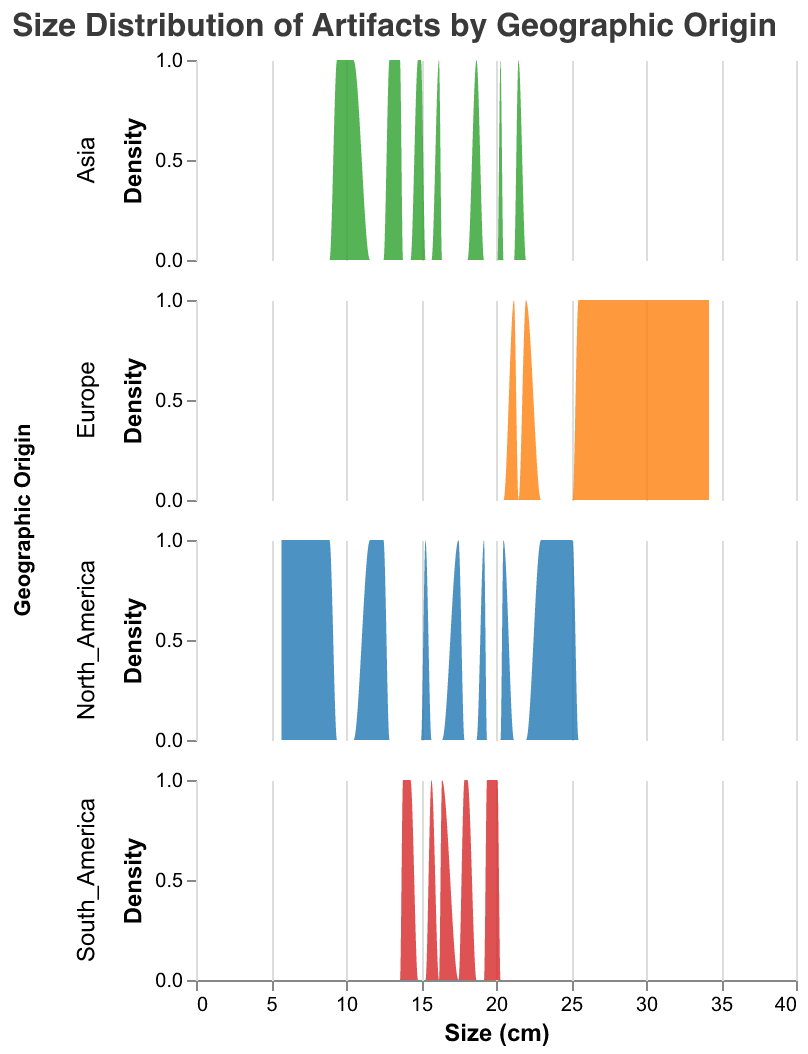What is the title of the figure? The title is given at the top of the figure, which is usually in a larger font size and often in a different color to stand out.
Answer: Size Distribution of Artifacts by Geographic Origin What is the x-axis representing in the figure? The x-axis is labeled "Size (cm)" and represents the size of the artifacts in centimeters.
Answer: Size (cm) Which geographic origin has artifacts with the largest maximum size? Look at the artifact sizes for each geographic origin. The largest maximum size can be identified from the highest data point in each subplot, which for Europe is about 34.2 cm.
Answer: Europe How does the size distribution of artifacts from North America compare to those from Asia? By observing the density plots for both North America and Asia, North America's artifacts are more spread out across a wider size range, while Asia's artifacts are more concentrated in the mid-size range. Specifically, North America's sizes range from approximately 5.7 cm to 25.1 cm, while Asia's range from 9.4 cm to 21.5 cm.
Answer: North America's distribution is wider; Asia's is more concentrated in the mid-sizes Which geographic origin has the smallest maximum size of artifacts? Look at the highest point on the x-axis for each geographic origin. Asia has artifacts with the smallest maximum size at 21.5 cm.
Answer: Asia What's the range of artifact sizes from South America? The range can be calculated by subtracting the minimum size value from the maximum size value for South America, which are approximately 13.8 cm and 20.1 cm respectively. Thus, the range is 20.1 - 13.8 = 6.3 cm.
Answer: 6.3 cm In which geographic origin do artifacts tend to have sizes clustered in a specific range? Observing the density plots, Europe shows a strong clustering around 25-34 cm, indicating a higher density of sizes in this range compared to others.
Answer: Europe 